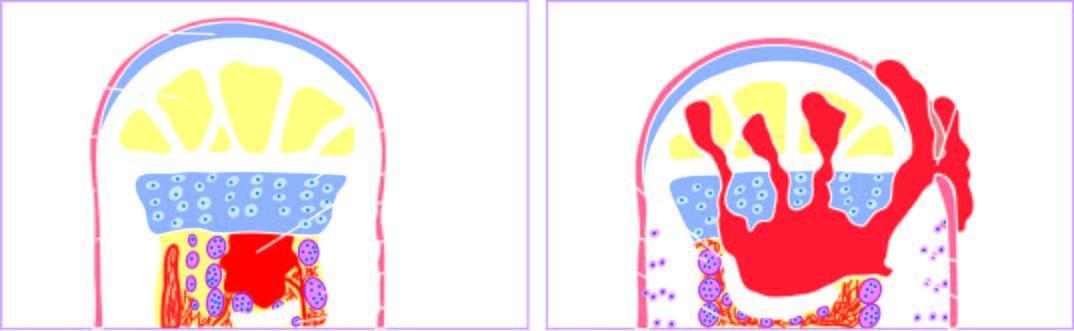s there beginning of reactive woven bone formation by the periosteum?
Answer the question using a single word or phrase. Yes 